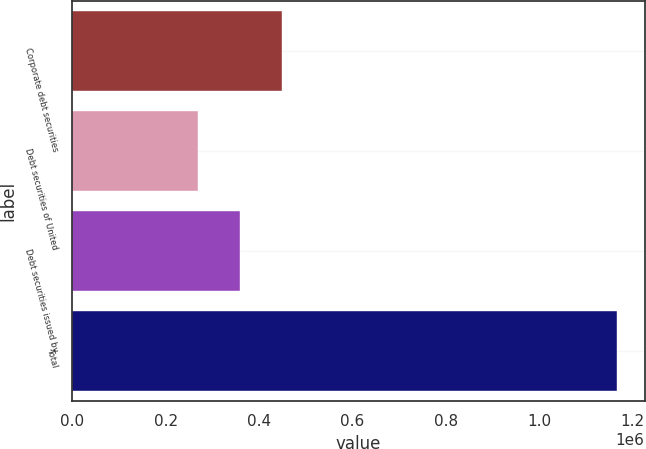Convert chart. <chart><loc_0><loc_0><loc_500><loc_500><bar_chart><fcel>Corporate debt securities<fcel>Debt securities of United<fcel>Debt securities issued by<fcel>Total<nl><fcel>449279<fcel>269571<fcel>359425<fcel>1.16811e+06<nl></chart> 